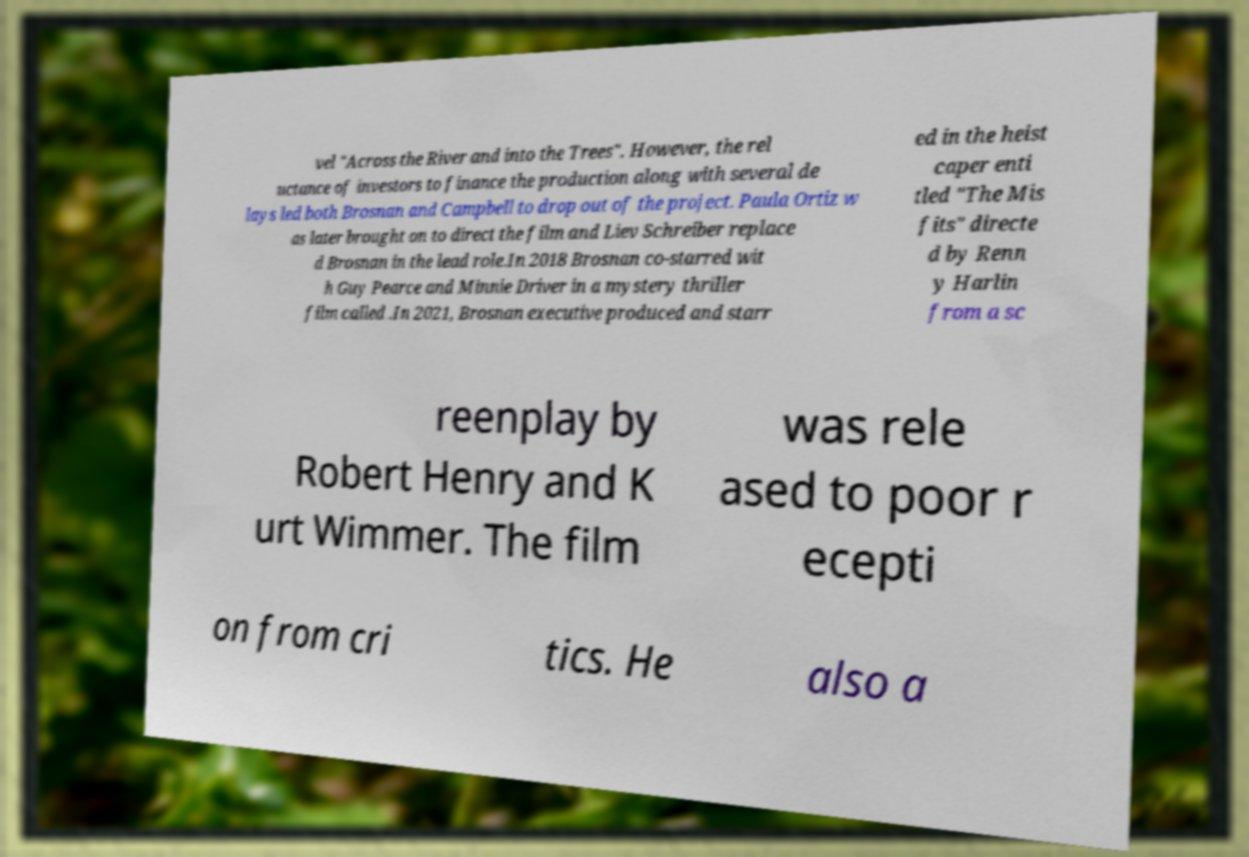What messages or text are displayed in this image? I need them in a readable, typed format. vel "Across the River and into the Trees". However, the rel uctance of investors to finance the production along with several de lays led both Brosnan and Campbell to drop out of the project. Paula Ortiz w as later brought on to direct the film and Liev Schreiber replace d Brosnan in the lead role.In 2018 Brosnan co-starred wit h Guy Pearce and Minnie Driver in a mystery thriller film called .In 2021, Brosnan executive produced and starr ed in the heist caper enti tled "The Mis fits" directe d by Renn y Harlin from a sc reenplay by Robert Henry and K urt Wimmer. The film was rele ased to poor r ecepti on from cri tics. He also a 